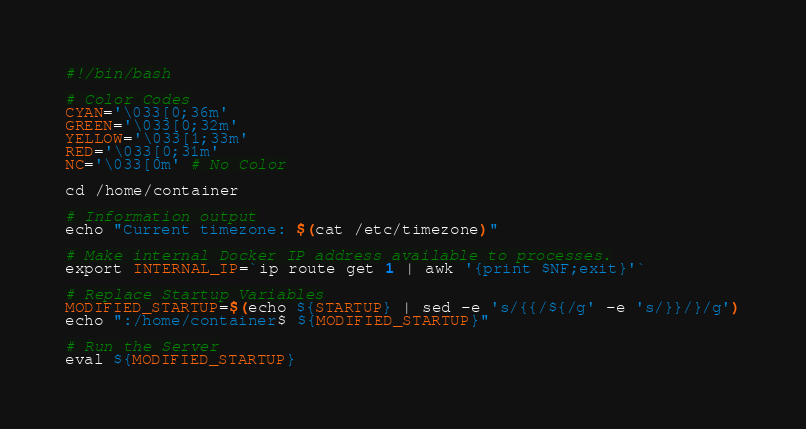<code> <loc_0><loc_0><loc_500><loc_500><_Bash_>#!/bin/bash

# Color Codes
CYAN='\033[0;36m'
GREEN='\033[0;32m'
YELLOW='\033[1;33m'
RED='\033[0;31m'
NC='\033[0m' # No Color

cd /home/container

# Information output
echo "Current timezone: $(cat /etc/timezone)"

# Make internal Docker IP address available to processes.
export INTERNAL_IP=`ip route get 1 | awk '{print $NF;exit}'`

# Replace Startup Variables
MODIFIED_STARTUP=$(echo ${STARTUP} | sed -e 's/{{/${/g' -e 's/}}/}/g')
echo ":/home/container$ ${MODIFIED_STARTUP}"

# Run the Server
eval ${MODIFIED_STARTUP}
</code> 